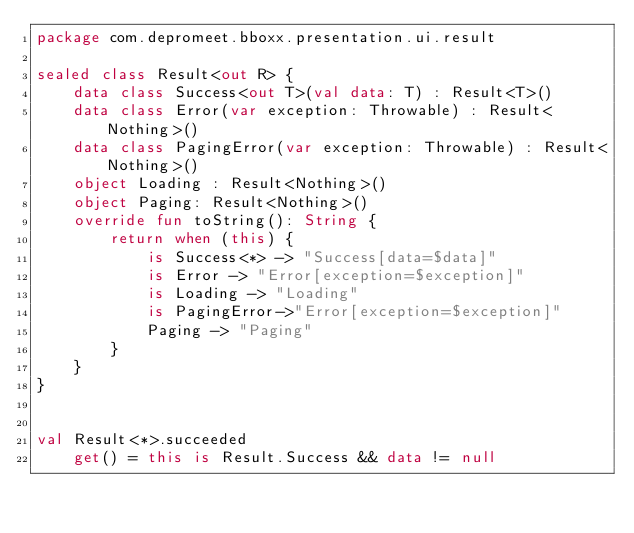Convert code to text. <code><loc_0><loc_0><loc_500><loc_500><_Kotlin_>package com.depromeet.bboxx.presentation.ui.result

sealed class Result<out R> {
    data class Success<out T>(val data: T) : Result<T>()
    data class Error(var exception: Throwable) : Result<Nothing>()
    data class PagingError(var exception: Throwable) : Result<Nothing>()
    object Loading : Result<Nothing>()
    object Paging: Result<Nothing>()
    override fun toString(): String {
        return when (this) {
            is Success<*> -> "Success[data=$data]"
            is Error -> "Error[exception=$exception]"
            is Loading -> "Loading"
            is PagingError->"Error[exception=$exception]"
            Paging -> "Paging"
        }
    }
}


val Result<*>.succeeded
    get() = this is Result.Success && data != null
</code> 